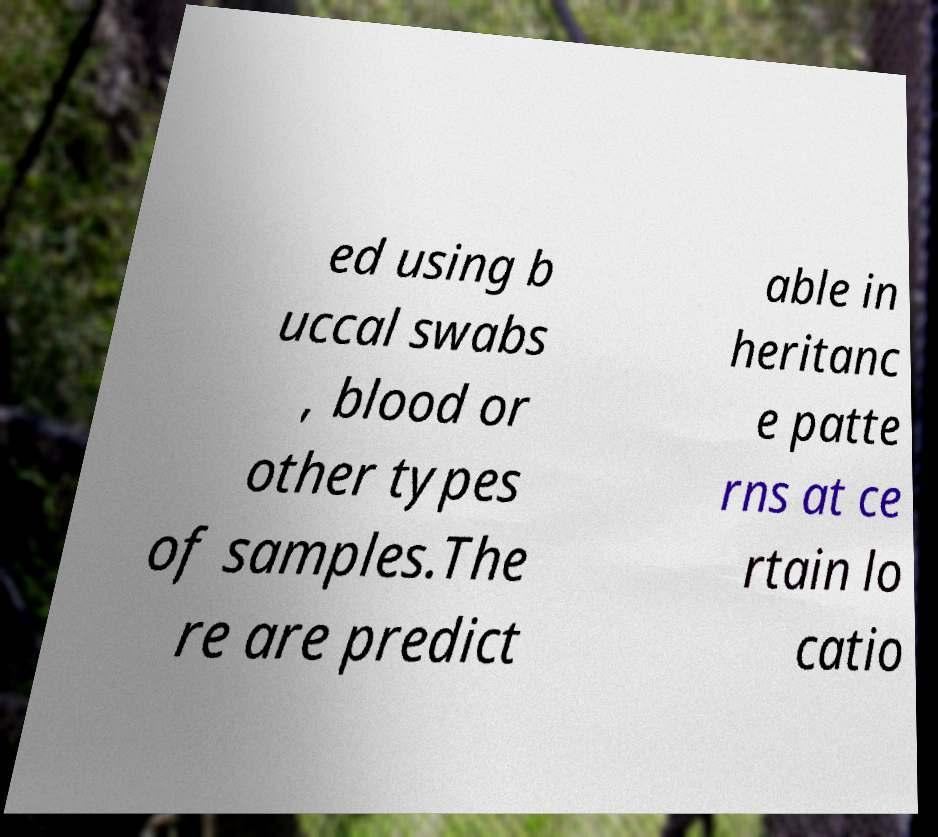For documentation purposes, I need the text within this image transcribed. Could you provide that? ed using b uccal swabs , blood or other types of samples.The re are predict able in heritanc e patte rns at ce rtain lo catio 